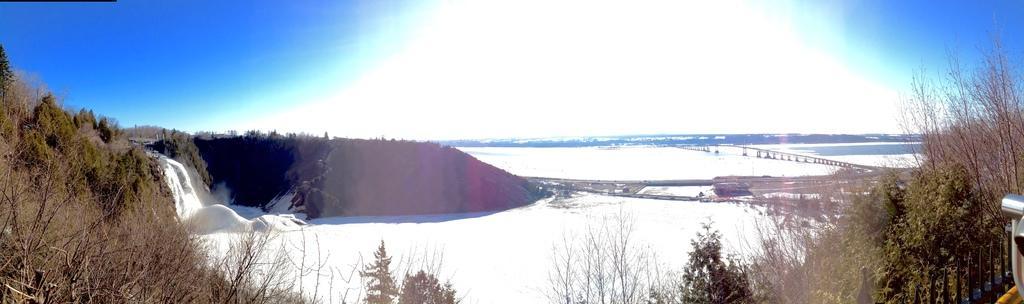Describe this image in one or two sentences. In this image there is snow on the ground. In the center there are mountains. On the either sides of the image there are plants and trees. To the right there is a bridge behind the plants. At the top there is the sky. 